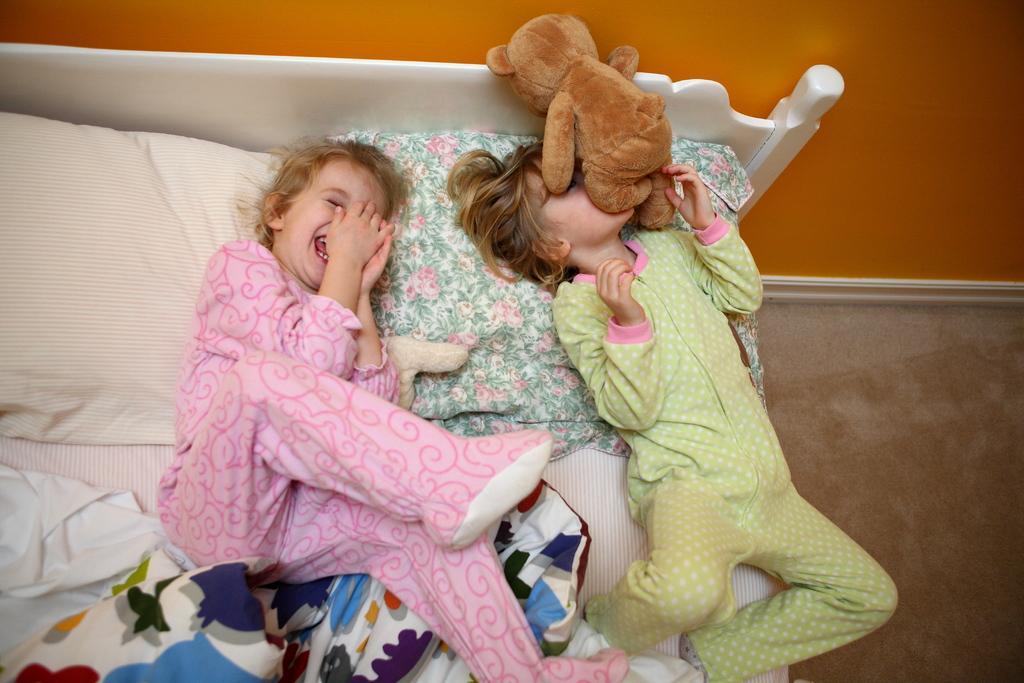Describe this image in one or two sentences. In this image we can see two children playing on the bed. There is a teddy bear on one child's face. On the backside we can see a wall and the floor. 